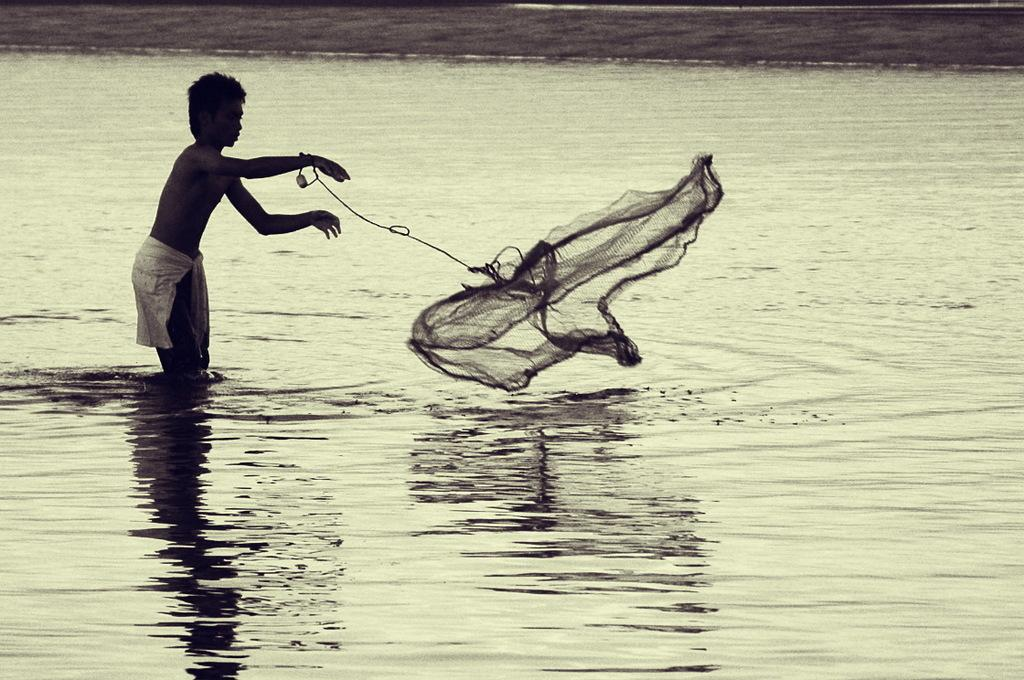Who is present in the image? There is a boy in the image. What is the boy doing in the image? The boy is standing in water and holding a fishing net with his hand. What type of distribution is the boy responsible for in the image? There is no mention of distribution in the image, and the boy is not responsible for any distribution. 